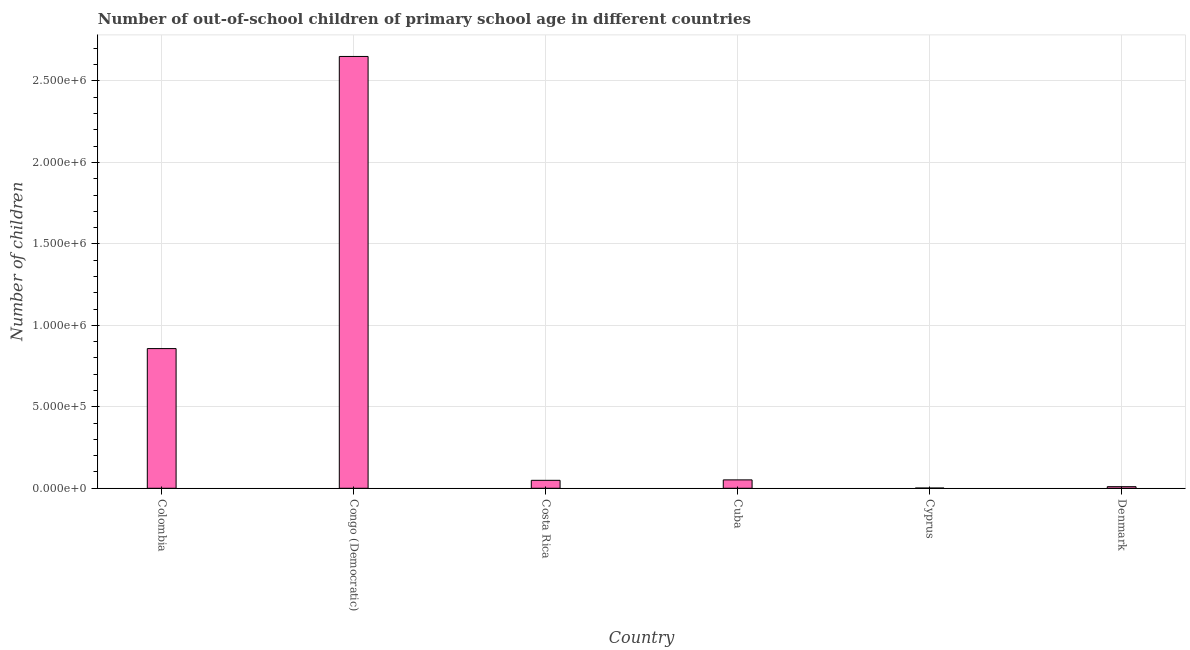What is the title of the graph?
Your answer should be compact. Number of out-of-school children of primary school age in different countries. What is the label or title of the X-axis?
Your response must be concise. Country. What is the label or title of the Y-axis?
Your response must be concise. Number of children. What is the number of out-of-school children in Cyprus?
Offer a terse response. 1508. Across all countries, what is the maximum number of out-of-school children?
Provide a succinct answer. 2.65e+06. Across all countries, what is the minimum number of out-of-school children?
Ensure brevity in your answer.  1508. In which country was the number of out-of-school children maximum?
Make the answer very short. Congo (Democratic). In which country was the number of out-of-school children minimum?
Make the answer very short. Cyprus. What is the sum of the number of out-of-school children?
Offer a very short reply. 3.62e+06. What is the difference between the number of out-of-school children in Colombia and Cuba?
Your answer should be very brief. 8.06e+05. What is the average number of out-of-school children per country?
Provide a succinct answer. 6.03e+05. What is the median number of out-of-school children?
Give a very brief answer. 5.02e+04. In how many countries, is the number of out-of-school children greater than 1400000 ?
Ensure brevity in your answer.  1. What is the ratio of the number of out-of-school children in Costa Rica to that in Cyprus?
Your answer should be compact. 32.39. Is the number of out-of-school children in Cuba less than that in Cyprus?
Offer a terse response. No. What is the difference between the highest and the second highest number of out-of-school children?
Your answer should be very brief. 1.79e+06. Is the sum of the number of out-of-school children in Cuba and Denmark greater than the maximum number of out-of-school children across all countries?
Your answer should be compact. No. What is the difference between the highest and the lowest number of out-of-school children?
Make the answer very short. 2.65e+06. In how many countries, is the number of out-of-school children greater than the average number of out-of-school children taken over all countries?
Give a very brief answer. 2. What is the difference between two consecutive major ticks on the Y-axis?
Keep it short and to the point. 5.00e+05. What is the Number of children of Colombia?
Provide a short and direct response. 8.57e+05. What is the Number of children in Congo (Democratic)?
Provide a succinct answer. 2.65e+06. What is the Number of children in Costa Rica?
Offer a terse response. 4.88e+04. What is the Number of children of Cuba?
Make the answer very short. 5.16e+04. What is the Number of children of Cyprus?
Provide a short and direct response. 1508. What is the Number of children of Denmark?
Make the answer very short. 9848. What is the difference between the Number of children in Colombia and Congo (Democratic)?
Give a very brief answer. -1.79e+06. What is the difference between the Number of children in Colombia and Costa Rica?
Your answer should be compact. 8.09e+05. What is the difference between the Number of children in Colombia and Cuba?
Give a very brief answer. 8.06e+05. What is the difference between the Number of children in Colombia and Cyprus?
Offer a terse response. 8.56e+05. What is the difference between the Number of children in Colombia and Denmark?
Offer a terse response. 8.48e+05. What is the difference between the Number of children in Congo (Democratic) and Costa Rica?
Offer a terse response. 2.60e+06. What is the difference between the Number of children in Congo (Democratic) and Cuba?
Provide a succinct answer. 2.60e+06. What is the difference between the Number of children in Congo (Democratic) and Cyprus?
Offer a very short reply. 2.65e+06. What is the difference between the Number of children in Congo (Democratic) and Denmark?
Your response must be concise. 2.64e+06. What is the difference between the Number of children in Costa Rica and Cuba?
Make the answer very short. -2732. What is the difference between the Number of children in Costa Rica and Cyprus?
Offer a terse response. 4.73e+04. What is the difference between the Number of children in Costa Rica and Denmark?
Your answer should be very brief. 3.90e+04. What is the difference between the Number of children in Cuba and Cyprus?
Provide a short and direct response. 5.01e+04. What is the difference between the Number of children in Cuba and Denmark?
Make the answer very short. 4.17e+04. What is the difference between the Number of children in Cyprus and Denmark?
Offer a terse response. -8340. What is the ratio of the Number of children in Colombia to that in Congo (Democratic)?
Give a very brief answer. 0.32. What is the ratio of the Number of children in Colombia to that in Costa Rica?
Make the answer very short. 17.55. What is the ratio of the Number of children in Colombia to that in Cuba?
Provide a succinct answer. 16.62. What is the ratio of the Number of children in Colombia to that in Cyprus?
Your answer should be compact. 568.58. What is the ratio of the Number of children in Colombia to that in Denmark?
Keep it short and to the point. 87.07. What is the ratio of the Number of children in Congo (Democratic) to that in Costa Rica?
Your answer should be very brief. 54.26. What is the ratio of the Number of children in Congo (Democratic) to that in Cuba?
Offer a terse response. 51.38. What is the ratio of the Number of children in Congo (Democratic) to that in Cyprus?
Provide a short and direct response. 1757.52. What is the ratio of the Number of children in Congo (Democratic) to that in Denmark?
Make the answer very short. 269.12. What is the ratio of the Number of children in Costa Rica to that in Cuba?
Your response must be concise. 0.95. What is the ratio of the Number of children in Costa Rica to that in Cyprus?
Provide a succinct answer. 32.39. What is the ratio of the Number of children in Costa Rica to that in Denmark?
Provide a short and direct response. 4.96. What is the ratio of the Number of children in Cuba to that in Cyprus?
Make the answer very short. 34.2. What is the ratio of the Number of children in Cuba to that in Denmark?
Provide a short and direct response. 5.24. What is the ratio of the Number of children in Cyprus to that in Denmark?
Make the answer very short. 0.15. 